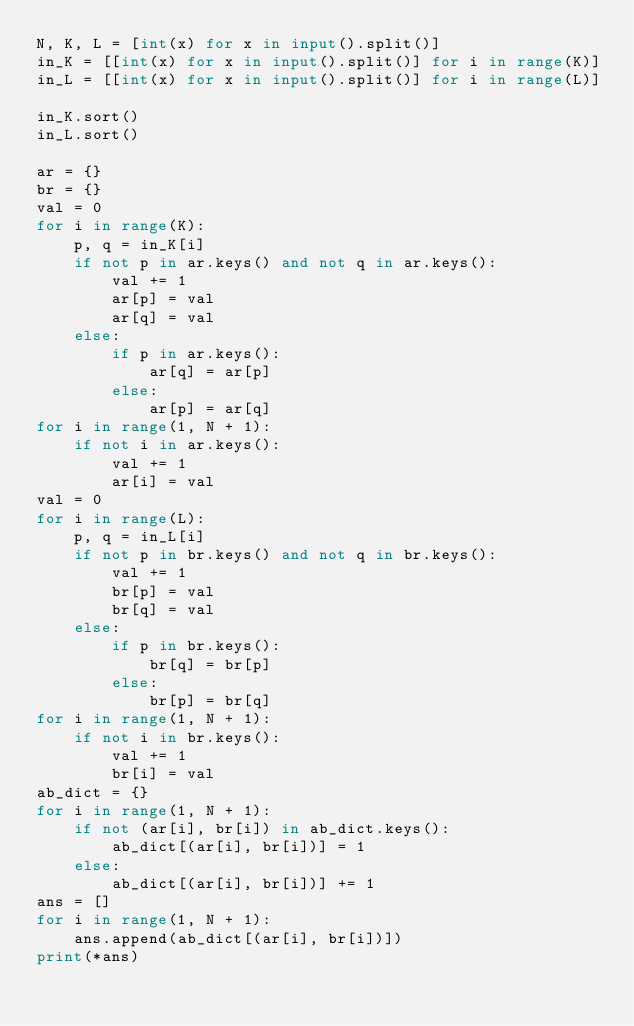<code> <loc_0><loc_0><loc_500><loc_500><_Python_>N, K, L = [int(x) for x in input().split()]
in_K = [[int(x) for x in input().split()] for i in range(K)]
in_L = [[int(x) for x in input().split()] for i in range(L)]

in_K.sort()
in_L.sort()

ar = {}
br = {}
val = 0
for i in range(K):
    p, q = in_K[i]
    if not p in ar.keys() and not q in ar.keys():
        val += 1
        ar[p] = val
        ar[q] = val
    else:
        if p in ar.keys():
            ar[q] = ar[p]
        else:
            ar[p] = ar[q]
for i in range(1, N + 1):
    if not i in ar.keys():
        val += 1
        ar[i] = val
val = 0
for i in range(L):
    p, q = in_L[i]
    if not p in br.keys() and not q in br.keys():
        val += 1
        br[p] = val
        br[q] = val
    else:
        if p in br.keys():
            br[q] = br[p]
        else:
            br[p] = br[q]
for i in range(1, N + 1):
    if not i in br.keys():
        val += 1
        br[i] = val
ab_dict = {}
for i in range(1, N + 1):
    if not (ar[i], br[i]) in ab_dict.keys():
        ab_dict[(ar[i], br[i])] = 1
    else:
        ab_dict[(ar[i], br[i])] += 1
ans = []
for i in range(1, N + 1):
    ans.append(ab_dict[(ar[i], br[i])])
print(*ans)
</code> 